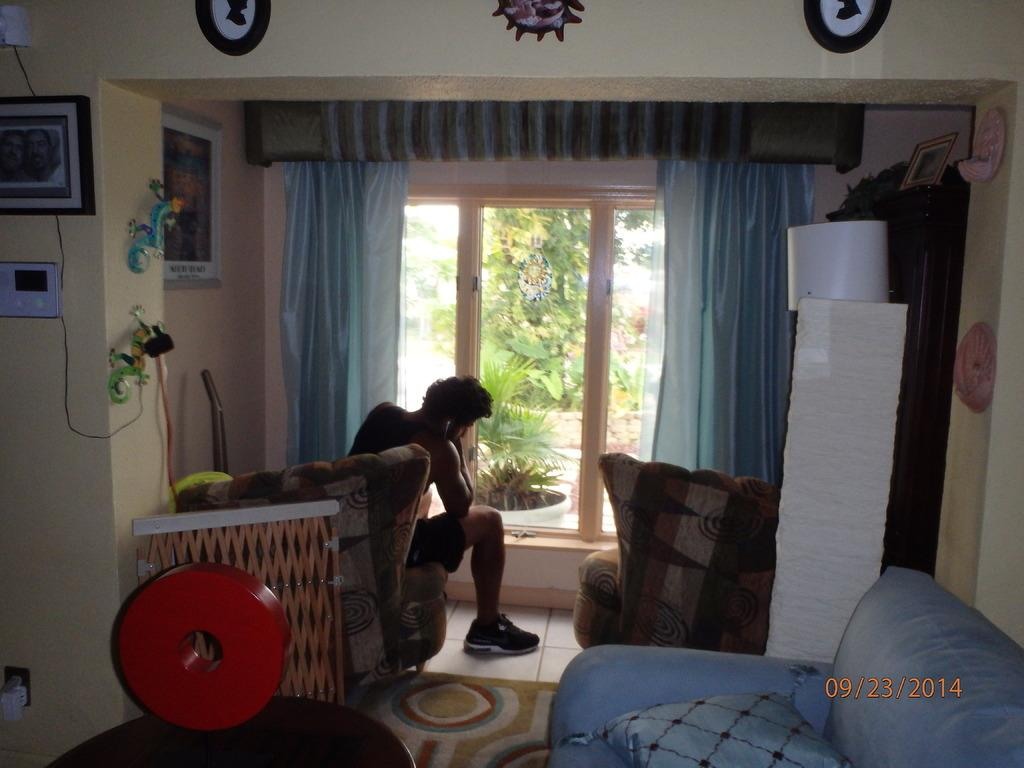What is the man in the image sitting on? The man is sitting on a couch in the image. Can you describe the couch in the image? There is a sofa in the image, and it has a cushion on it. What can be seen in the background of the image? In the background of the image, there are curtains, frames on the wall, and plants. What type of train can be seen passing by in the image? There is no train present in the image; it features a man sitting on a couch with a sofa, cushion, curtains, frames, and plants in the background. Can you tell me how many airplanes are visible in the image? There are no airplanes visible in the image. 